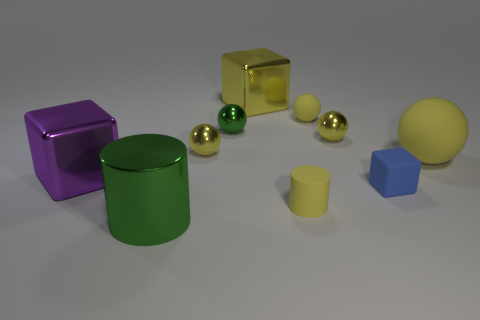Is the color of the rubber cylinder the same as the big sphere?
Your answer should be compact. Yes. Do the sphere that is right of the tiny blue thing and the small metallic ball that is to the right of the big yellow metallic thing have the same color?
Offer a terse response. Yes. Is there a metal ball of the same color as the matte cylinder?
Provide a succinct answer. Yes. What size is the other rubber sphere that is the same color as the tiny matte sphere?
Ensure brevity in your answer.  Large. There is a large shiny thing that is the same color as the small cylinder; what shape is it?
Provide a short and direct response. Cube. What is the green cylinder made of?
Give a very brief answer. Metal. Is the material of the blue object the same as the large yellow thing that is to the right of the rubber block?
Offer a terse response. Yes. Is there anything else that is the same color as the rubber block?
Provide a succinct answer. No. There is a large purple metal object that is left of the big thing that is to the right of the tiny cylinder; are there any spheres that are behind it?
Ensure brevity in your answer.  Yes. The large matte ball is what color?
Offer a very short reply. Yellow. 